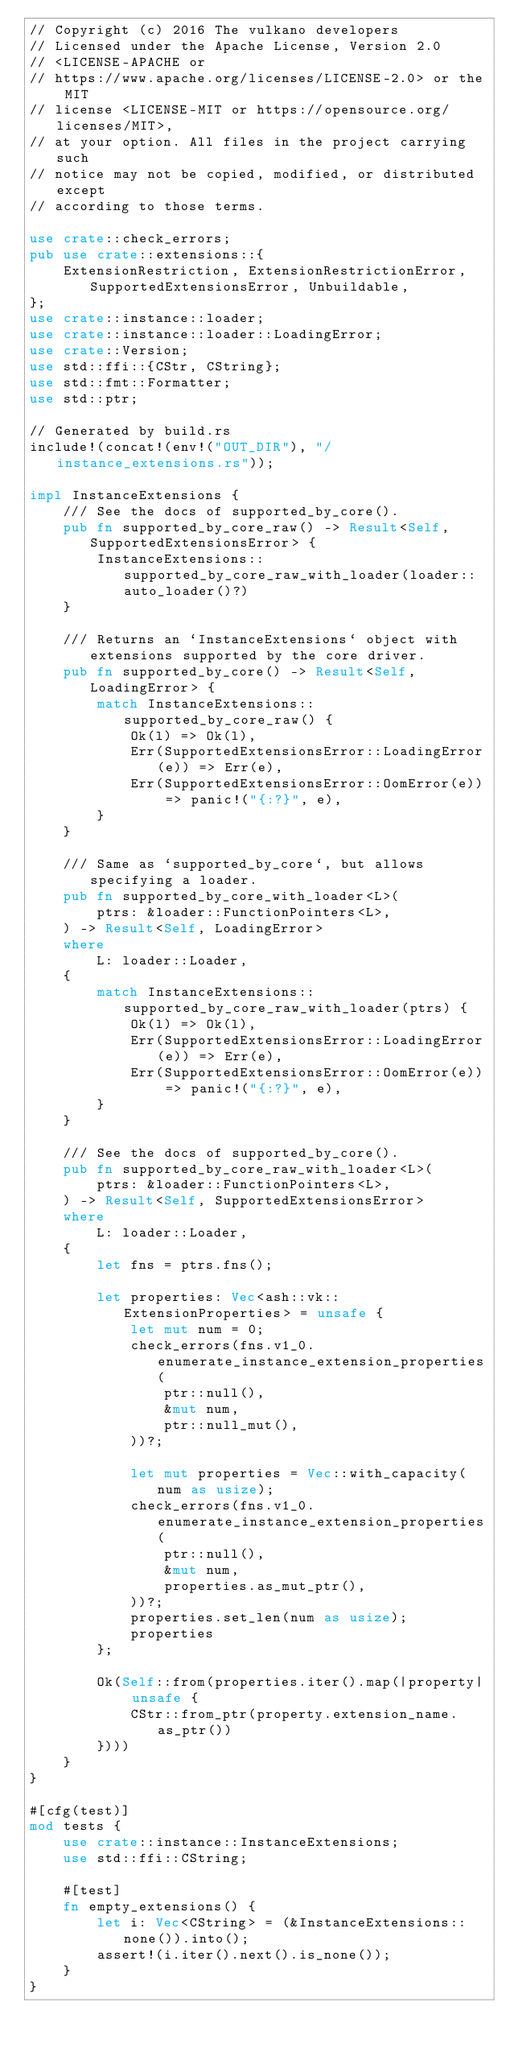Convert code to text. <code><loc_0><loc_0><loc_500><loc_500><_Rust_>// Copyright (c) 2016 The vulkano developers
// Licensed under the Apache License, Version 2.0
// <LICENSE-APACHE or
// https://www.apache.org/licenses/LICENSE-2.0> or the MIT
// license <LICENSE-MIT or https://opensource.org/licenses/MIT>,
// at your option. All files in the project carrying such
// notice may not be copied, modified, or distributed except
// according to those terms.

use crate::check_errors;
pub use crate::extensions::{
    ExtensionRestriction, ExtensionRestrictionError, SupportedExtensionsError, Unbuildable,
};
use crate::instance::loader;
use crate::instance::loader::LoadingError;
use crate::Version;
use std::ffi::{CStr, CString};
use std::fmt::Formatter;
use std::ptr;

// Generated by build.rs
include!(concat!(env!("OUT_DIR"), "/instance_extensions.rs"));

impl InstanceExtensions {
    /// See the docs of supported_by_core().
    pub fn supported_by_core_raw() -> Result<Self, SupportedExtensionsError> {
        InstanceExtensions::supported_by_core_raw_with_loader(loader::auto_loader()?)
    }

    /// Returns an `InstanceExtensions` object with extensions supported by the core driver.
    pub fn supported_by_core() -> Result<Self, LoadingError> {
        match InstanceExtensions::supported_by_core_raw() {
            Ok(l) => Ok(l),
            Err(SupportedExtensionsError::LoadingError(e)) => Err(e),
            Err(SupportedExtensionsError::OomError(e)) => panic!("{:?}", e),
        }
    }

    /// Same as `supported_by_core`, but allows specifying a loader.
    pub fn supported_by_core_with_loader<L>(
        ptrs: &loader::FunctionPointers<L>,
    ) -> Result<Self, LoadingError>
    where
        L: loader::Loader,
    {
        match InstanceExtensions::supported_by_core_raw_with_loader(ptrs) {
            Ok(l) => Ok(l),
            Err(SupportedExtensionsError::LoadingError(e)) => Err(e),
            Err(SupportedExtensionsError::OomError(e)) => panic!("{:?}", e),
        }
    }

    /// See the docs of supported_by_core().
    pub fn supported_by_core_raw_with_loader<L>(
        ptrs: &loader::FunctionPointers<L>,
    ) -> Result<Self, SupportedExtensionsError>
    where
        L: loader::Loader,
    {
        let fns = ptrs.fns();

        let properties: Vec<ash::vk::ExtensionProperties> = unsafe {
            let mut num = 0;
            check_errors(fns.v1_0.enumerate_instance_extension_properties(
                ptr::null(),
                &mut num,
                ptr::null_mut(),
            ))?;

            let mut properties = Vec::with_capacity(num as usize);
            check_errors(fns.v1_0.enumerate_instance_extension_properties(
                ptr::null(),
                &mut num,
                properties.as_mut_ptr(),
            ))?;
            properties.set_len(num as usize);
            properties
        };

        Ok(Self::from(properties.iter().map(|property| unsafe {
            CStr::from_ptr(property.extension_name.as_ptr())
        })))
    }
}

#[cfg(test)]
mod tests {
    use crate::instance::InstanceExtensions;
    use std::ffi::CString;

    #[test]
    fn empty_extensions() {
        let i: Vec<CString> = (&InstanceExtensions::none()).into();
        assert!(i.iter().next().is_none());
    }
}
</code> 